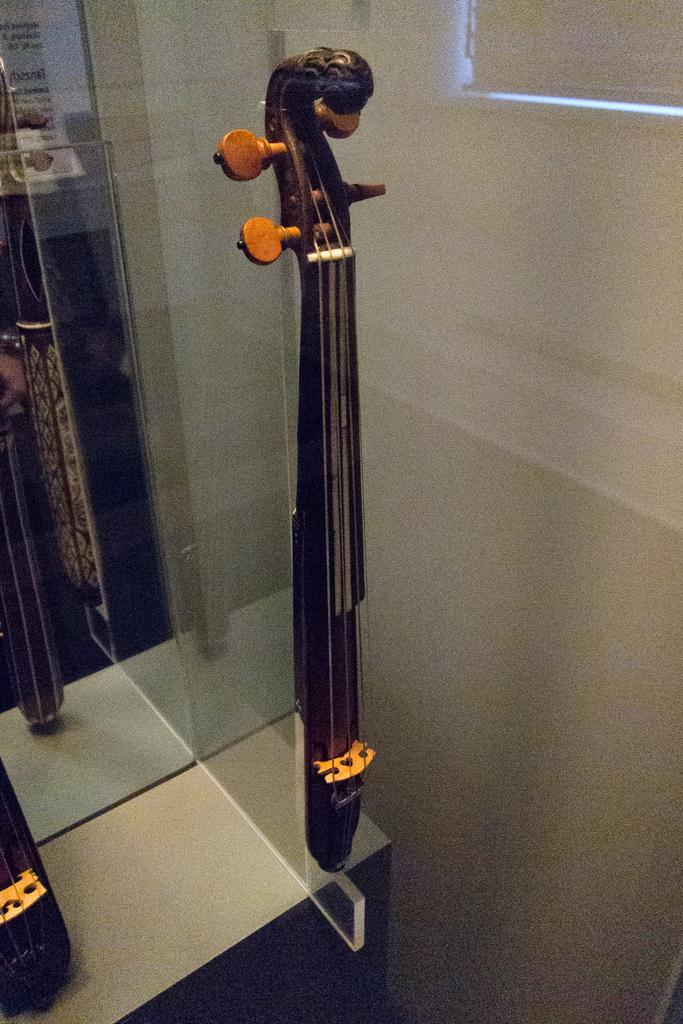What objects are present in the image that are related to music? There are musical instruments in the image. What colors are the musical instruments? The musical instruments are in brown and black color. What can be seen in the background of the image? There is a glass and a wall in the background of the image. What type of cabbage is being used as a drumstick in the image? There is no cabbage or drumstick present in the image; it features musical instruments in brown and black color. How many birds are perched on the musical instruments in the image? There are no birds present in the image; it only features musical instruments, a glass, and a wall in the background. 